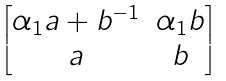<formula> <loc_0><loc_0><loc_500><loc_500>\begin{bmatrix} \alpha _ { 1 } a + b ^ { - 1 } & \alpha _ { 1 } b \\ a & b \end{bmatrix}</formula> 